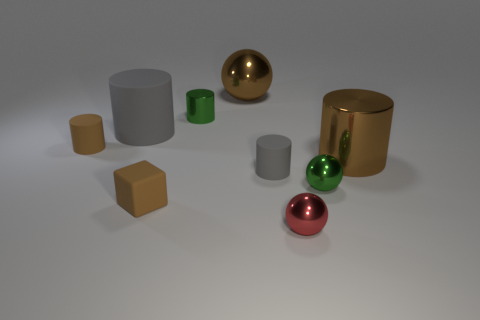How many brown cylinders must be subtracted to get 1 brown cylinders? 1 Subtract 2 cylinders. How many cylinders are left? 3 Subtract all green cylinders. How many cylinders are left? 4 Subtract all tiny gray cylinders. How many cylinders are left? 4 Subtract all cyan cylinders. Subtract all green cubes. How many cylinders are left? 5 Add 1 red objects. How many objects exist? 10 Subtract all blocks. How many objects are left? 8 Add 4 small blocks. How many small blocks are left? 5 Add 5 gray matte blocks. How many gray matte blocks exist? 5 Subtract 0 yellow cylinders. How many objects are left? 9 